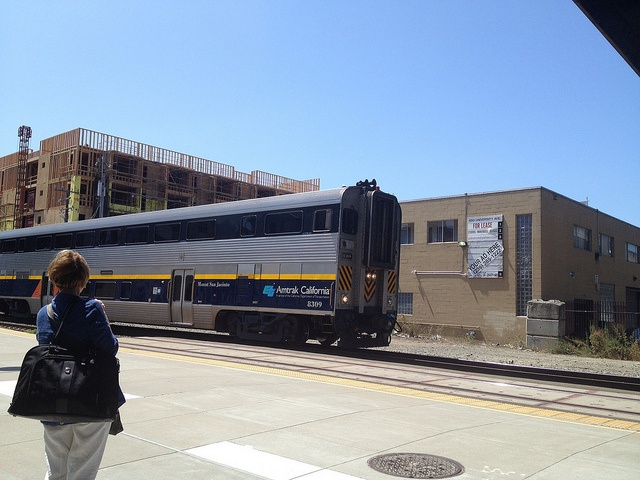Describe the objects in this image and their specific colors. I can see train in lightblue, black, gray, and darkgray tones, handbag in lightblue, black, gray, and lightgray tones, and people in lightblue, black, and gray tones in this image. 